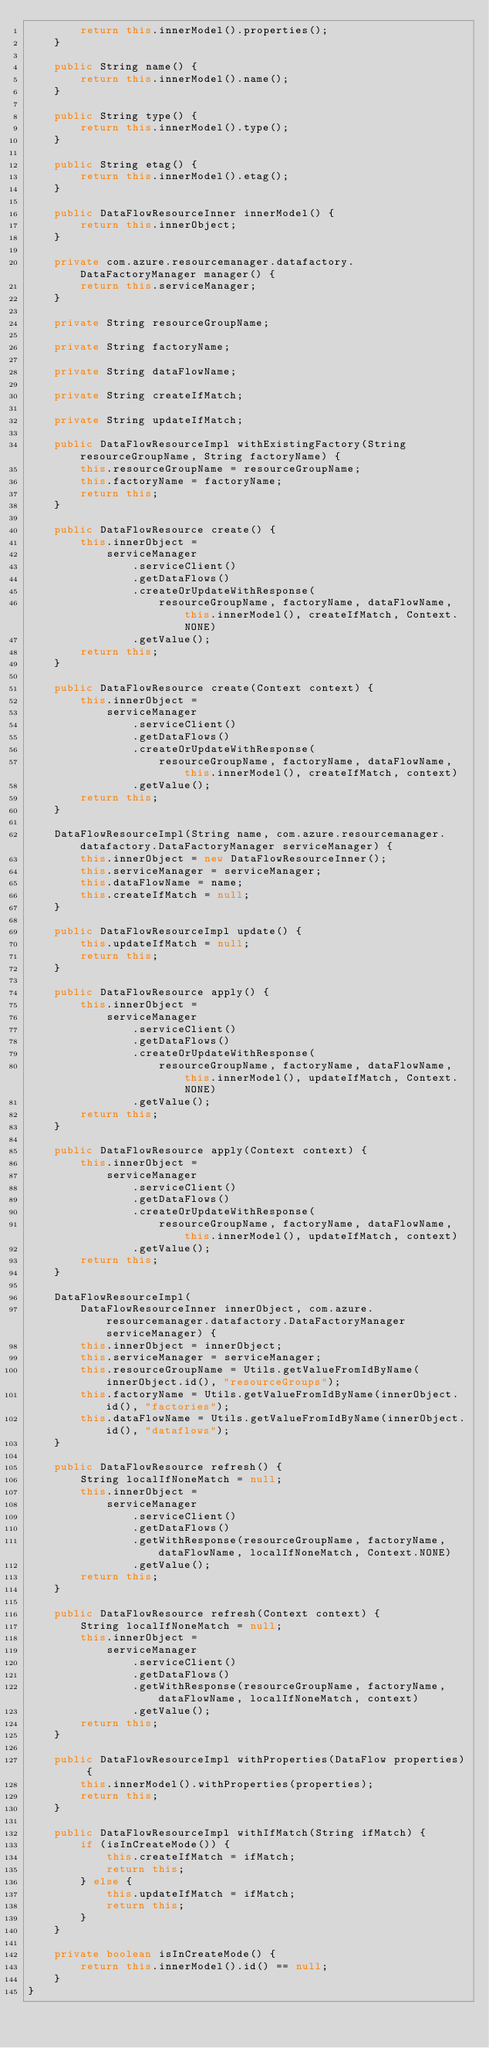<code> <loc_0><loc_0><loc_500><loc_500><_Java_>        return this.innerModel().properties();
    }

    public String name() {
        return this.innerModel().name();
    }

    public String type() {
        return this.innerModel().type();
    }

    public String etag() {
        return this.innerModel().etag();
    }

    public DataFlowResourceInner innerModel() {
        return this.innerObject;
    }

    private com.azure.resourcemanager.datafactory.DataFactoryManager manager() {
        return this.serviceManager;
    }

    private String resourceGroupName;

    private String factoryName;

    private String dataFlowName;

    private String createIfMatch;

    private String updateIfMatch;

    public DataFlowResourceImpl withExistingFactory(String resourceGroupName, String factoryName) {
        this.resourceGroupName = resourceGroupName;
        this.factoryName = factoryName;
        return this;
    }

    public DataFlowResource create() {
        this.innerObject =
            serviceManager
                .serviceClient()
                .getDataFlows()
                .createOrUpdateWithResponse(
                    resourceGroupName, factoryName, dataFlowName, this.innerModel(), createIfMatch, Context.NONE)
                .getValue();
        return this;
    }

    public DataFlowResource create(Context context) {
        this.innerObject =
            serviceManager
                .serviceClient()
                .getDataFlows()
                .createOrUpdateWithResponse(
                    resourceGroupName, factoryName, dataFlowName, this.innerModel(), createIfMatch, context)
                .getValue();
        return this;
    }

    DataFlowResourceImpl(String name, com.azure.resourcemanager.datafactory.DataFactoryManager serviceManager) {
        this.innerObject = new DataFlowResourceInner();
        this.serviceManager = serviceManager;
        this.dataFlowName = name;
        this.createIfMatch = null;
    }

    public DataFlowResourceImpl update() {
        this.updateIfMatch = null;
        return this;
    }

    public DataFlowResource apply() {
        this.innerObject =
            serviceManager
                .serviceClient()
                .getDataFlows()
                .createOrUpdateWithResponse(
                    resourceGroupName, factoryName, dataFlowName, this.innerModel(), updateIfMatch, Context.NONE)
                .getValue();
        return this;
    }

    public DataFlowResource apply(Context context) {
        this.innerObject =
            serviceManager
                .serviceClient()
                .getDataFlows()
                .createOrUpdateWithResponse(
                    resourceGroupName, factoryName, dataFlowName, this.innerModel(), updateIfMatch, context)
                .getValue();
        return this;
    }

    DataFlowResourceImpl(
        DataFlowResourceInner innerObject, com.azure.resourcemanager.datafactory.DataFactoryManager serviceManager) {
        this.innerObject = innerObject;
        this.serviceManager = serviceManager;
        this.resourceGroupName = Utils.getValueFromIdByName(innerObject.id(), "resourceGroups");
        this.factoryName = Utils.getValueFromIdByName(innerObject.id(), "factories");
        this.dataFlowName = Utils.getValueFromIdByName(innerObject.id(), "dataflows");
    }

    public DataFlowResource refresh() {
        String localIfNoneMatch = null;
        this.innerObject =
            serviceManager
                .serviceClient()
                .getDataFlows()
                .getWithResponse(resourceGroupName, factoryName, dataFlowName, localIfNoneMatch, Context.NONE)
                .getValue();
        return this;
    }

    public DataFlowResource refresh(Context context) {
        String localIfNoneMatch = null;
        this.innerObject =
            serviceManager
                .serviceClient()
                .getDataFlows()
                .getWithResponse(resourceGroupName, factoryName, dataFlowName, localIfNoneMatch, context)
                .getValue();
        return this;
    }

    public DataFlowResourceImpl withProperties(DataFlow properties) {
        this.innerModel().withProperties(properties);
        return this;
    }

    public DataFlowResourceImpl withIfMatch(String ifMatch) {
        if (isInCreateMode()) {
            this.createIfMatch = ifMatch;
            return this;
        } else {
            this.updateIfMatch = ifMatch;
            return this;
        }
    }

    private boolean isInCreateMode() {
        return this.innerModel().id() == null;
    }
}
</code> 